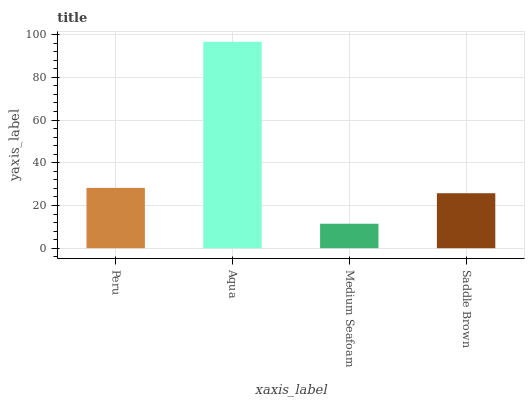Is Medium Seafoam the minimum?
Answer yes or no. Yes. Is Aqua the maximum?
Answer yes or no. Yes. Is Aqua the minimum?
Answer yes or no. No. Is Medium Seafoam the maximum?
Answer yes or no. No. Is Aqua greater than Medium Seafoam?
Answer yes or no. Yes. Is Medium Seafoam less than Aqua?
Answer yes or no. Yes. Is Medium Seafoam greater than Aqua?
Answer yes or no. No. Is Aqua less than Medium Seafoam?
Answer yes or no. No. Is Peru the high median?
Answer yes or no. Yes. Is Saddle Brown the low median?
Answer yes or no. Yes. Is Aqua the high median?
Answer yes or no. No. Is Peru the low median?
Answer yes or no. No. 